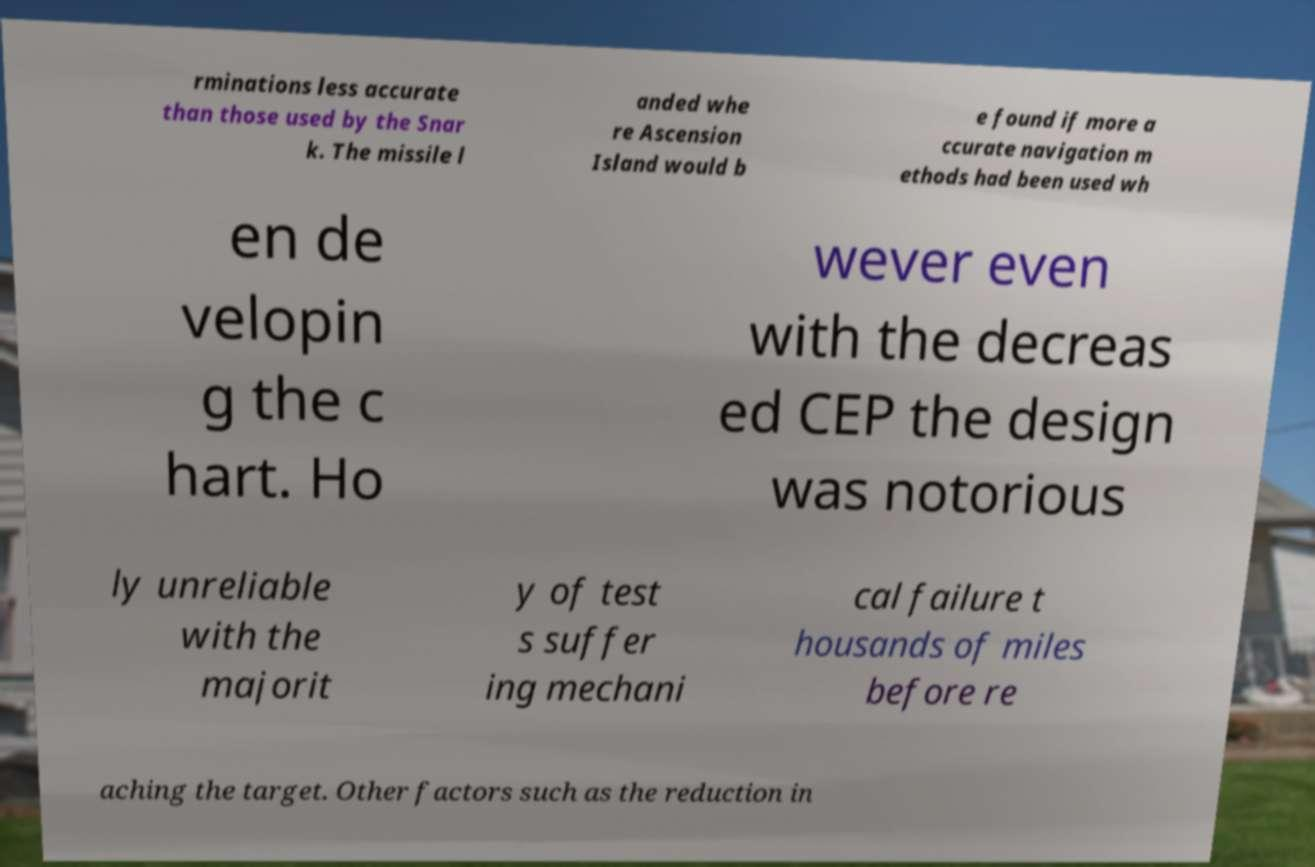I need the written content from this picture converted into text. Can you do that? rminations less accurate than those used by the Snar k. The missile l anded whe re Ascension Island would b e found if more a ccurate navigation m ethods had been used wh en de velopin g the c hart. Ho wever even with the decreas ed CEP the design was notorious ly unreliable with the majorit y of test s suffer ing mechani cal failure t housands of miles before re aching the target. Other factors such as the reduction in 